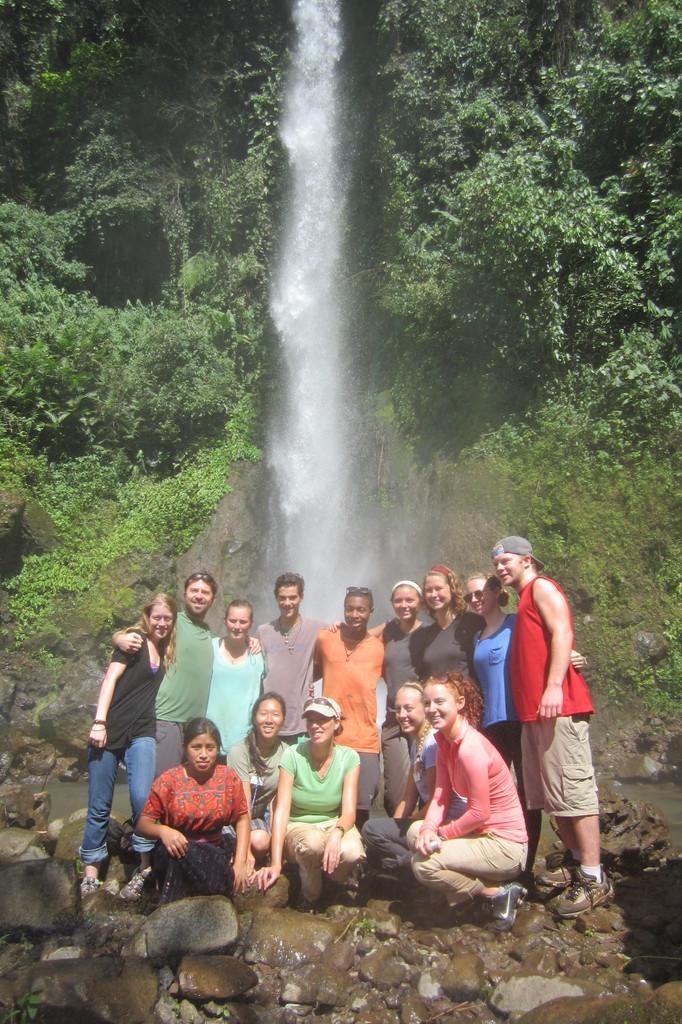How would you summarize this image in a sentence or two? In this picture we can see a group of people were some are standing and some are sitting on stones and at the back of them we can see trees, water. 